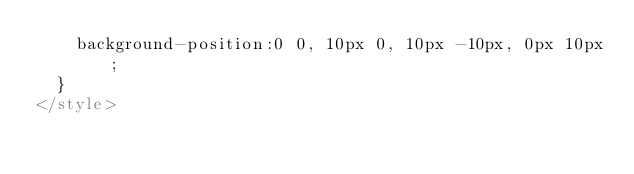<code> <loc_0><loc_0><loc_500><loc_500><_HTML_>    background-position:0 0, 10px 0, 10px -10px, 0px 10px;
  }
</style>
</code> 